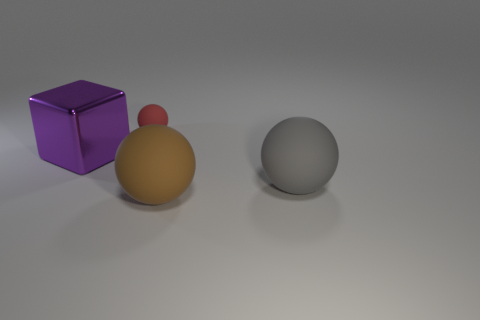Is there a specific meaning to the arrangement of objects? The image might be a visual metaphor or reflect principles of balance and contrast in composition. The arrangement could also be random, without a predetermined meaning. 